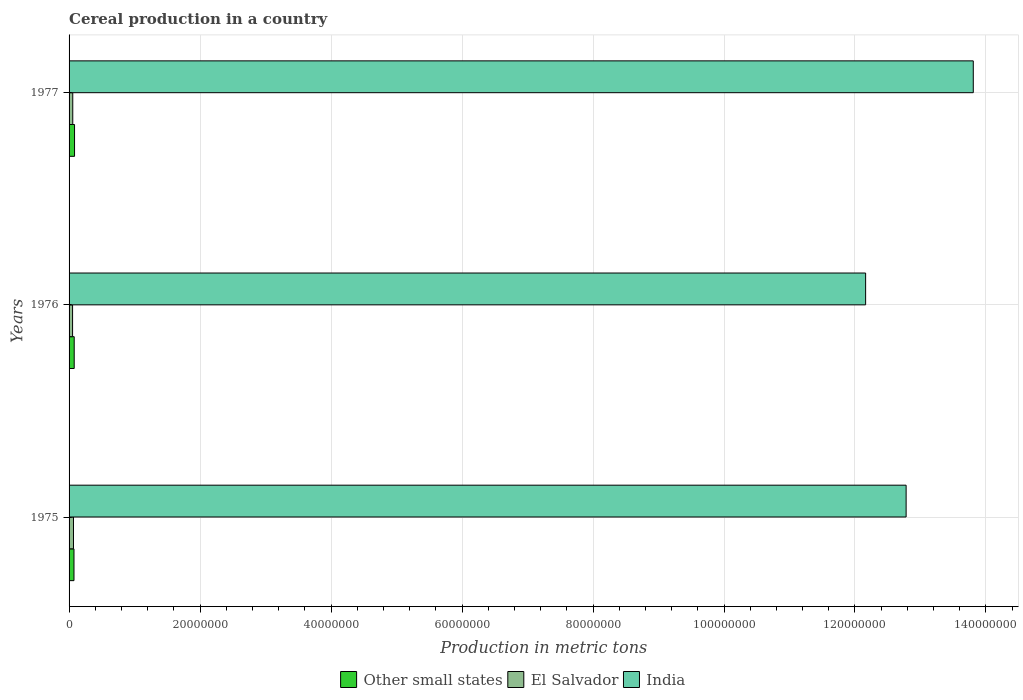Are the number of bars per tick equal to the number of legend labels?
Keep it short and to the point. Yes. Are the number of bars on each tick of the Y-axis equal?
Your response must be concise. Yes. How many bars are there on the 1st tick from the top?
Your response must be concise. 3. How many bars are there on the 3rd tick from the bottom?
Your answer should be very brief. 3. In how many cases, is the number of bars for a given year not equal to the number of legend labels?
Offer a terse response. 0. What is the total cereal production in Other small states in 1976?
Your answer should be compact. 7.85e+05. Across all years, what is the maximum total cereal production in India?
Offer a very short reply. 1.38e+08. Across all years, what is the minimum total cereal production in India?
Your response must be concise. 1.22e+08. In which year was the total cereal production in El Salvador maximum?
Offer a very short reply. 1975. In which year was the total cereal production in Other small states minimum?
Offer a very short reply. 1975. What is the total total cereal production in India in the graph?
Your answer should be compact. 3.87e+08. What is the difference between the total cereal production in Other small states in 1976 and that in 1977?
Provide a succinct answer. -5.08e+04. What is the difference between the total cereal production in Other small states in 1975 and the total cereal production in El Salvador in 1976?
Your answer should be very brief. 2.15e+05. What is the average total cereal production in India per year?
Make the answer very short. 1.29e+08. In the year 1977, what is the difference between the total cereal production in India and total cereal production in Other small states?
Provide a short and direct response. 1.37e+08. In how many years, is the total cereal production in Other small states greater than 88000000 metric tons?
Your answer should be very brief. 0. What is the ratio of the total cereal production in El Salvador in 1975 to that in 1976?
Provide a succinct answer. 1.26. Is the difference between the total cereal production in India in 1975 and 1976 greater than the difference between the total cereal production in Other small states in 1975 and 1976?
Offer a terse response. Yes. What is the difference between the highest and the second highest total cereal production in Other small states?
Ensure brevity in your answer.  5.08e+04. What is the difference between the highest and the lowest total cereal production in India?
Offer a very short reply. 1.64e+07. What does the 2nd bar from the bottom in 1976 represents?
Offer a terse response. El Salvador. Does the graph contain grids?
Provide a succinct answer. Yes. How many legend labels are there?
Provide a succinct answer. 3. What is the title of the graph?
Offer a terse response. Cereal production in a country. Does "Europe(developing only)" appear as one of the legend labels in the graph?
Offer a terse response. No. What is the label or title of the X-axis?
Offer a terse response. Production in metric tons. What is the Production in metric tons of Other small states in 1975?
Your response must be concise. 7.50e+05. What is the Production in metric tons of El Salvador in 1975?
Ensure brevity in your answer.  6.75e+05. What is the Production in metric tons in India in 1975?
Give a very brief answer. 1.28e+08. What is the Production in metric tons in Other small states in 1976?
Your response must be concise. 7.85e+05. What is the Production in metric tons in El Salvador in 1976?
Your response must be concise. 5.34e+05. What is the Production in metric tons in India in 1976?
Offer a terse response. 1.22e+08. What is the Production in metric tons in Other small states in 1977?
Provide a short and direct response. 8.36e+05. What is the Production in metric tons in El Salvador in 1977?
Your answer should be very brief. 5.64e+05. What is the Production in metric tons of India in 1977?
Make the answer very short. 1.38e+08. Across all years, what is the maximum Production in metric tons of Other small states?
Offer a terse response. 8.36e+05. Across all years, what is the maximum Production in metric tons of El Salvador?
Keep it short and to the point. 6.75e+05. Across all years, what is the maximum Production in metric tons of India?
Your answer should be compact. 1.38e+08. Across all years, what is the minimum Production in metric tons of Other small states?
Your answer should be compact. 7.50e+05. Across all years, what is the minimum Production in metric tons in El Salvador?
Provide a short and direct response. 5.34e+05. Across all years, what is the minimum Production in metric tons of India?
Give a very brief answer. 1.22e+08. What is the total Production in metric tons of Other small states in the graph?
Make the answer very short. 2.37e+06. What is the total Production in metric tons in El Salvador in the graph?
Provide a short and direct response. 1.77e+06. What is the total Production in metric tons of India in the graph?
Offer a very short reply. 3.87e+08. What is the difference between the Production in metric tons of Other small states in 1975 and that in 1976?
Your answer should be very brief. -3.51e+04. What is the difference between the Production in metric tons in El Salvador in 1975 and that in 1976?
Make the answer very short. 1.40e+05. What is the difference between the Production in metric tons of India in 1975 and that in 1976?
Offer a terse response. 6.18e+06. What is the difference between the Production in metric tons of Other small states in 1975 and that in 1977?
Make the answer very short. -8.59e+04. What is the difference between the Production in metric tons of El Salvador in 1975 and that in 1977?
Your answer should be very brief. 1.11e+05. What is the difference between the Production in metric tons of India in 1975 and that in 1977?
Your response must be concise. -1.03e+07. What is the difference between the Production in metric tons in Other small states in 1976 and that in 1977?
Your response must be concise. -5.08e+04. What is the difference between the Production in metric tons of El Salvador in 1976 and that in 1977?
Keep it short and to the point. -2.91e+04. What is the difference between the Production in metric tons in India in 1976 and that in 1977?
Make the answer very short. -1.64e+07. What is the difference between the Production in metric tons of Other small states in 1975 and the Production in metric tons of El Salvador in 1976?
Provide a short and direct response. 2.15e+05. What is the difference between the Production in metric tons in Other small states in 1975 and the Production in metric tons in India in 1976?
Your answer should be compact. -1.21e+08. What is the difference between the Production in metric tons in El Salvador in 1975 and the Production in metric tons in India in 1976?
Give a very brief answer. -1.21e+08. What is the difference between the Production in metric tons in Other small states in 1975 and the Production in metric tons in El Salvador in 1977?
Your answer should be very brief. 1.86e+05. What is the difference between the Production in metric tons of Other small states in 1975 and the Production in metric tons of India in 1977?
Your answer should be compact. -1.37e+08. What is the difference between the Production in metric tons in El Salvador in 1975 and the Production in metric tons in India in 1977?
Your answer should be very brief. -1.37e+08. What is the difference between the Production in metric tons in Other small states in 1976 and the Production in metric tons in El Salvador in 1977?
Provide a succinct answer. 2.21e+05. What is the difference between the Production in metric tons of Other small states in 1976 and the Production in metric tons of India in 1977?
Your response must be concise. -1.37e+08. What is the difference between the Production in metric tons in El Salvador in 1976 and the Production in metric tons in India in 1977?
Keep it short and to the point. -1.38e+08. What is the average Production in metric tons of Other small states per year?
Give a very brief answer. 7.90e+05. What is the average Production in metric tons in El Salvador per year?
Your answer should be very brief. 5.91e+05. What is the average Production in metric tons in India per year?
Provide a short and direct response. 1.29e+08. In the year 1975, what is the difference between the Production in metric tons in Other small states and Production in metric tons in El Salvador?
Offer a very short reply. 7.49e+04. In the year 1975, what is the difference between the Production in metric tons of Other small states and Production in metric tons of India?
Offer a terse response. -1.27e+08. In the year 1975, what is the difference between the Production in metric tons in El Salvador and Production in metric tons in India?
Offer a very short reply. -1.27e+08. In the year 1976, what is the difference between the Production in metric tons in Other small states and Production in metric tons in El Salvador?
Your response must be concise. 2.50e+05. In the year 1976, what is the difference between the Production in metric tons of Other small states and Production in metric tons of India?
Keep it short and to the point. -1.21e+08. In the year 1976, what is the difference between the Production in metric tons in El Salvador and Production in metric tons in India?
Keep it short and to the point. -1.21e+08. In the year 1977, what is the difference between the Production in metric tons in Other small states and Production in metric tons in El Salvador?
Your answer should be compact. 2.72e+05. In the year 1977, what is the difference between the Production in metric tons in Other small states and Production in metric tons in India?
Keep it short and to the point. -1.37e+08. In the year 1977, what is the difference between the Production in metric tons of El Salvador and Production in metric tons of India?
Your answer should be very brief. -1.37e+08. What is the ratio of the Production in metric tons in Other small states in 1975 to that in 1976?
Provide a succinct answer. 0.96. What is the ratio of the Production in metric tons of El Salvador in 1975 to that in 1976?
Keep it short and to the point. 1.26. What is the ratio of the Production in metric tons of India in 1975 to that in 1976?
Your answer should be compact. 1.05. What is the ratio of the Production in metric tons of Other small states in 1975 to that in 1977?
Your answer should be very brief. 0.9. What is the ratio of the Production in metric tons of El Salvador in 1975 to that in 1977?
Your response must be concise. 1.2. What is the ratio of the Production in metric tons in India in 1975 to that in 1977?
Offer a terse response. 0.93. What is the ratio of the Production in metric tons in Other small states in 1976 to that in 1977?
Give a very brief answer. 0.94. What is the ratio of the Production in metric tons in El Salvador in 1976 to that in 1977?
Keep it short and to the point. 0.95. What is the ratio of the Production in metric tons of India in 1976 to that in 1977?
Give a very brief answer. 0.88. What is the difference between the highest and the second highest Production in metric tons in Other small states?
Give a very brief answer. 5.08e+04. What is the difference between the highest and the second highest Production in metric tons of El Salvador?
Your response must be concise. 1.11e+05. What is the difference between the highest and the second highest Production in metric tons of India?
Offer a very short reply. 1.03e+07. What is the difference between the highest and the lowest Production in metric tons of Other small states?
Your answer should be compact. 8.59e+04. What is the difference between the highest and the lowest Production in metric tons in El Salvador?
Your response must be concise. 1.40e+05. What is the difference between the highest and the lowest Production in metric tons in India?
Your response must be concise. 1.64e+07. 